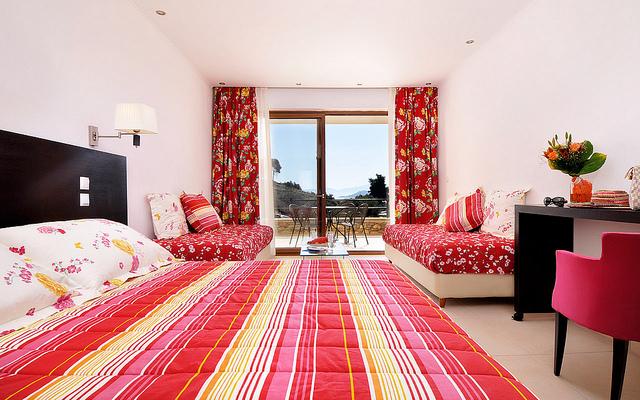What color is the chair in the foreground?
Short answer required. Pink. What pattern is on the drapes?
Be succinct. Floral. Is there a light on the wall?
Be succinct. Yes. 